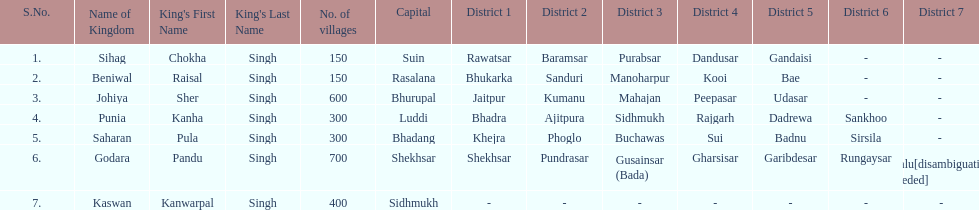How many districts does punia have? 6. 